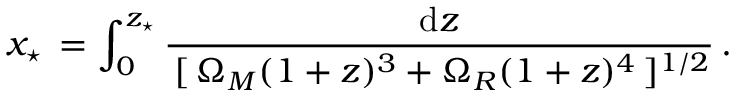Convert formula to latex. <formula><loc_0><loc_0><loc_500><loc_500>x _ { ^ { * } } \, = \int _ { 0 } ^ { z _ { ^ { * } } } \frac { d z } { \, [ \, \Omega _ { M } ( 1 + z ) ^ { 3 } + \Omega _ { R } ( 1 + z ) ^ { 4 } \, ] ^ { 1 / 2 } } \, .</formula> 